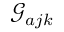<formula> <loc_0><loc_0><loc_500><loc_500>\mathcal { G } _ { a j k }</formula> 